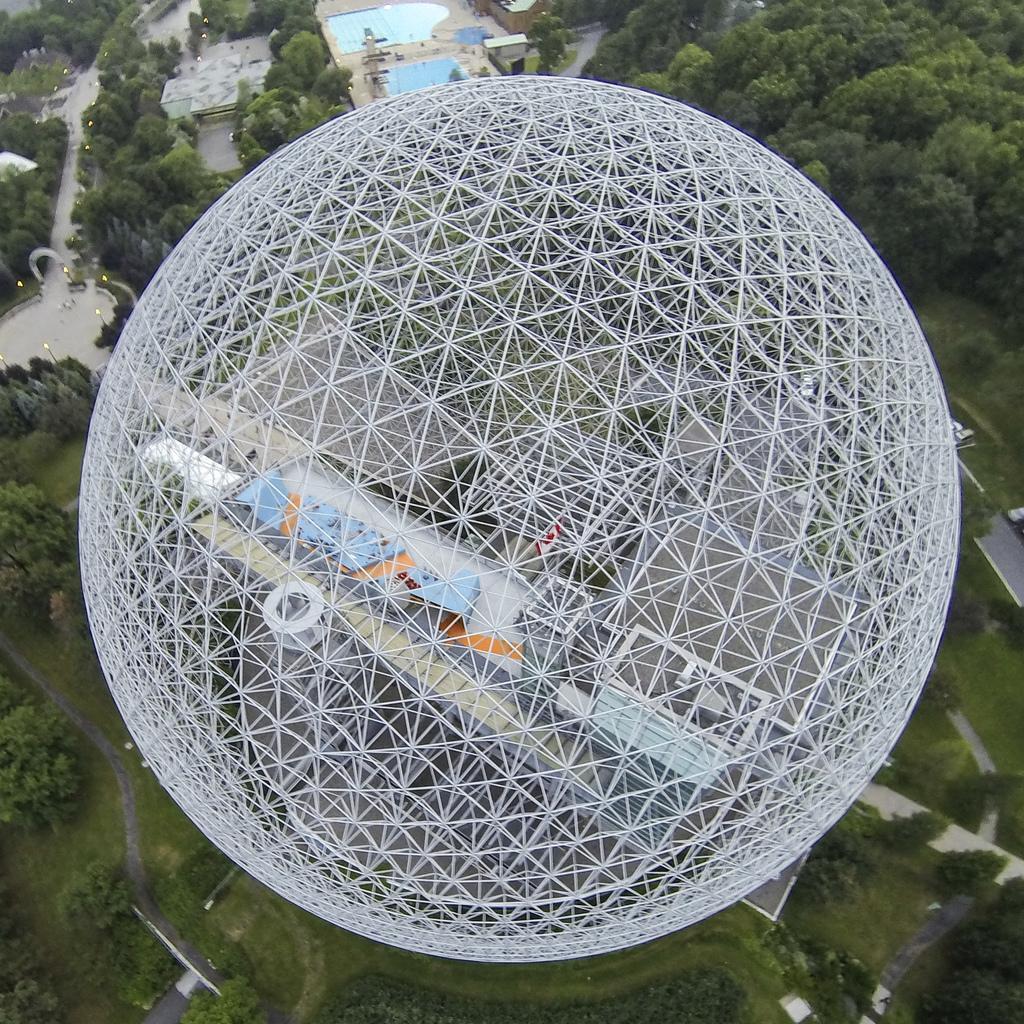How would you summarize this image in a sentence or two? This is the aerial view of the picture. In the middle, it looks like a dome and below that, we see the buildings. At the bottom, we see the road, grass and the trees. On the left side, we see the road, street lights and trees. There are buildings and the trees in the background. 